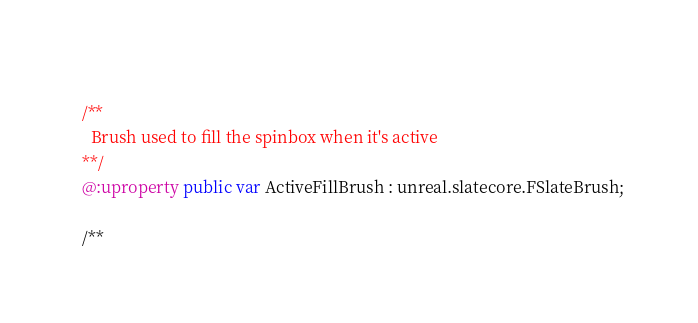Convert code to text. <code><loc_0><loc_0><loc_500><loc_500><_Haxe_>  
  /**
    Brush used to fill the spinbox when it's active
  **/
  @:uproperty public var ActiveFillBrush : unreal.slatecore.FSlateBrush;
  
  /**</code> 